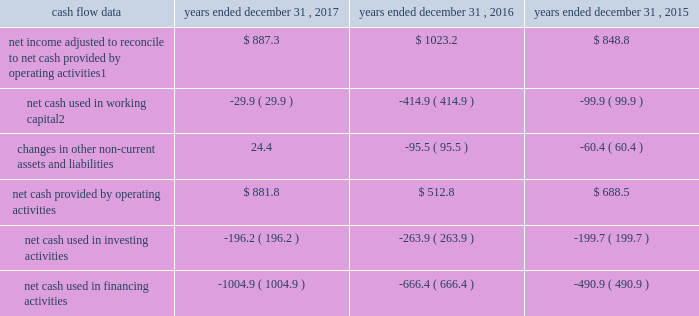Management 2019s discussion and analysis of financial condition and results of operations 2013 ( continued ) ( amounts in millions , except per share amounts ) operating income increased during 2017 when compared to 2016 , comprised of a decrease in revenue of $ 42.1 , as discussed above , a decrease in salaries and related expenses of $ 28.0 and a decrease in office and general expenses of $ 16.9 .
The decrease in salaries and related expenses was primarily due to lower discretionary bonuses and incentive expense as well as a decrease in base salaries , benefits and tax .
The decrease in office and general expenses was primarily due to decreases in adjustments to contingent acquisition obligations , as compared to the prior year .
Operating income increased during 2016 when compared to 2015 due to an increase in revenue of $ 58.8 , as discussed above , and a decrease in office and general expenses of $ 3.7 , partially offset by an increase in salaries and related expenses of $ 38.8 .
The increase in salaries and related expenses was attributable to an increase in base salaries , benefits and tax primarily due to increases in our workforce to support business growth over the last twelve months .
The decrease in office and general expenses was primarily due to lower production expenses related to pass-through costs , which are also reflected in revenue , for certain projects in which we acted as principal that decreased in size or did not recur during the current year .
Corporate and other certain corporate and other charges are reported as a separate line item within total segment operating income and include corporate office expenses , as well as shared service center and certain other centrally managed expenses that are not fully allocated to operating divisions .
Salaries and related expenses include salaries , long-term incentives , annual bonuses and other miscellaneous benefits for corporate office employees .
Office and general expenses primarily include professional fees related to internal control compliance , financial statement audits and legal , information technology and other consulting services that are engaged and managed through the corporate office .
Office and general expenses also include rental expense and depreciation of leasehold improvements for properties occupied by corporate office employees .
A portion of centrally managed expenses are allocated to operating divisions based on a formula that uses the planned revenues of each of the operating units .
Amounts allocated also include specific charges for information technology-related projects , which are allocated based on utilization .
Corporate and other expenses decreased during 2017 by $ 20.6 to $ 126.6 compared to 2016 , primarily due to lower annual incentive expense .
Corporate and other expenses increased during 2016 by $ 5.4 to $ 147.2 compared to 2015 .
Liquidity and capital resources cash flow overview the tables summarize key financial data relating to our liquidity , capital resources and uses of capital. .
1 reflects net income adjusted primarily for depreciation and amortization of fixed assets and intangible assets , amortization of restricted stock and other non-cash compensation , net losses on sales of businesses and deferred income taxes .
2 reflects changes in accounts receivable , expenditures billable to clients , other current assets , accounts payable and accrued liabilities .
Operating activities due to the seasonality of our business , we typically use cash from working capital in the first nine months of a year , with the largest impact in the first quarter , and generate cash from working capital in the fourth quarter , driven by the seasonally strong media spending by our clients .
Quarterly and annual working capital results are impacted by the fluctuating annual media spending budgets of our clients as well as their changing media spending patterns throughout each year across various countries. .
What is the net change in cash for 2016? 
Computations: ((512.8 + -263.9) / -666.4)
Answer: -0.3735. 